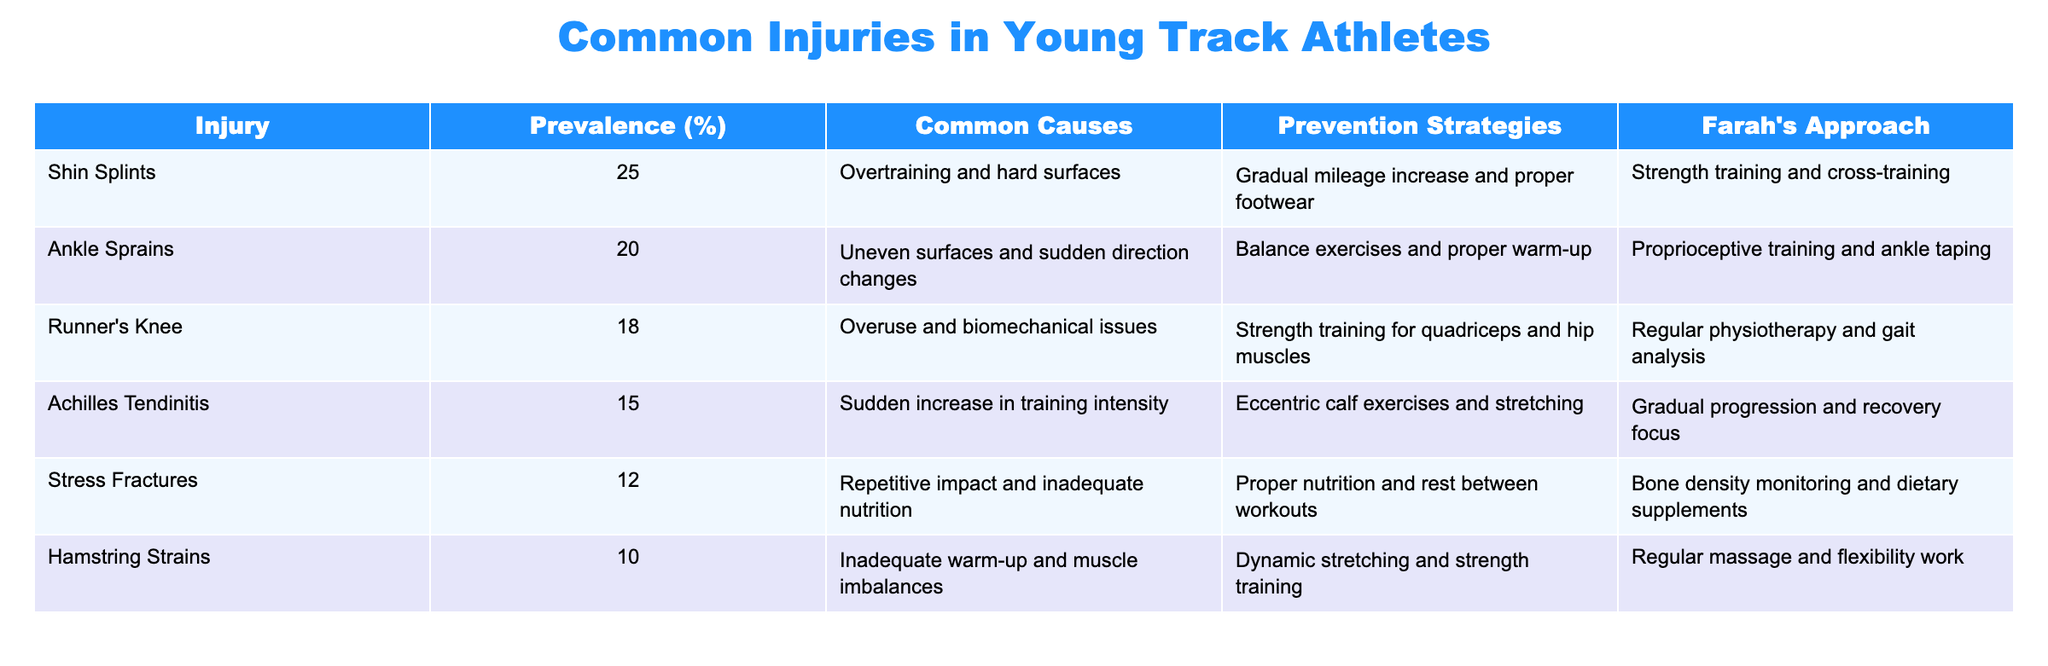What is the most common injury among young track athletes? The table shows that shin splints have a prevalence of 25%, making it the most common injury listed.
Answer: Shin Splints What percentage of injuries do ankle sprains account for? According to the table, ankle sprains account for 20% of injuries, as stated in the prevalence column.
Answer: 20% What are the common causes of runner's knee? The table indicates that the common causes of runner's knee are overuse and biomechanical issues, which can be found in the respective column.
Answer: Overuse and biomechanical issues What injury has the lowest prevalence and what is its percentage? By looking at the prevalence percentages in the table, stress fractures have the lowest occurrence at 12%.
Answer: Stress Fractures, 12% Which prevention strategy is recommended for Achilles tendinitis? The table suggests that eccentric calf exercises and stretching are the prevention strategies for Achilles tendinitis, found in the corresponding column.
Answer: Eccentric calf exercises and stretching Are more than half of the listed injuries caused by overuse? By adding the prevalence percentages of runner's knee, shin splints, and Achilles tendinitis, we find (18 + 25 + 15) = 58%, which is indeed more than half.
Answer: Yes How many injuries listed have a prevalence of 15% or more? The table shows the following injuries with prevalence percentages of 15% or more: shin splints (25%), ankle sprains (20%), runner's knee (18%), and Achilles tendinitis (15%). This gives us a total of four injuries.
Answer: 4 If a coach wants to target strength training for prevention, which two injuries should they focus on? The table indicates that runner's knee and hamstring strains recommend strength training as a prevention strategy. Therefore, a coach should focus on these two injuries.
Answer: Runner's Knee and Hamstring Strains What is the difference in prevalence between stress fractures and ankle sprains? From the table, ankle sprains have a prevalence of 20%, while stress fractures have 12%. Thus, the difference is (20 - 12) = 8%.
Answer: 8% 